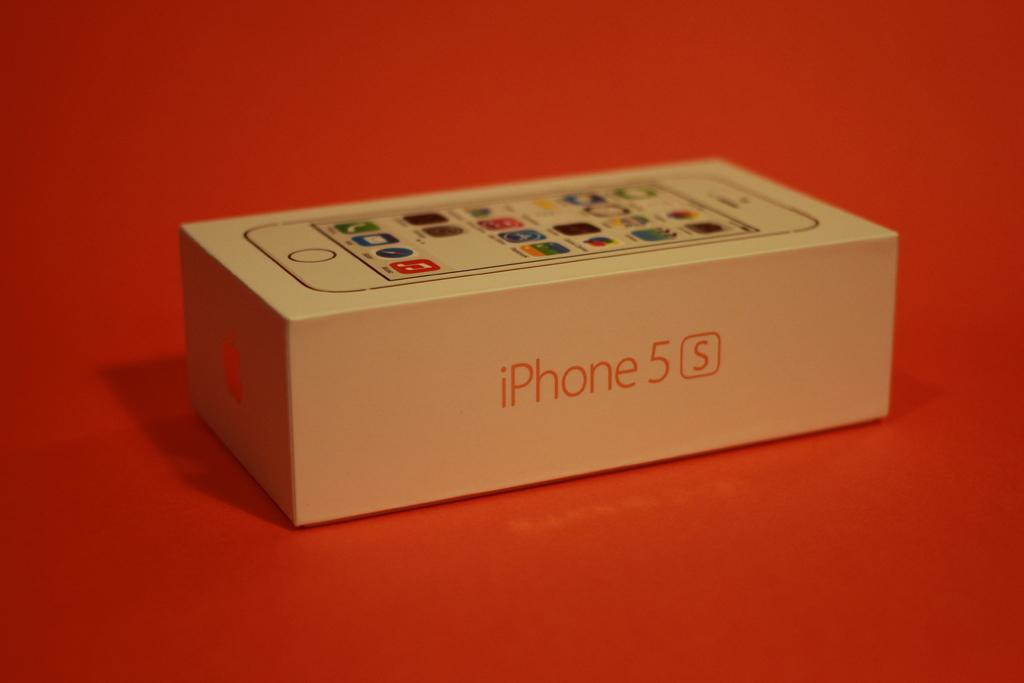Provide a one-sentence caption for the provided image. A box with iPhone 5 S typed on the side. 